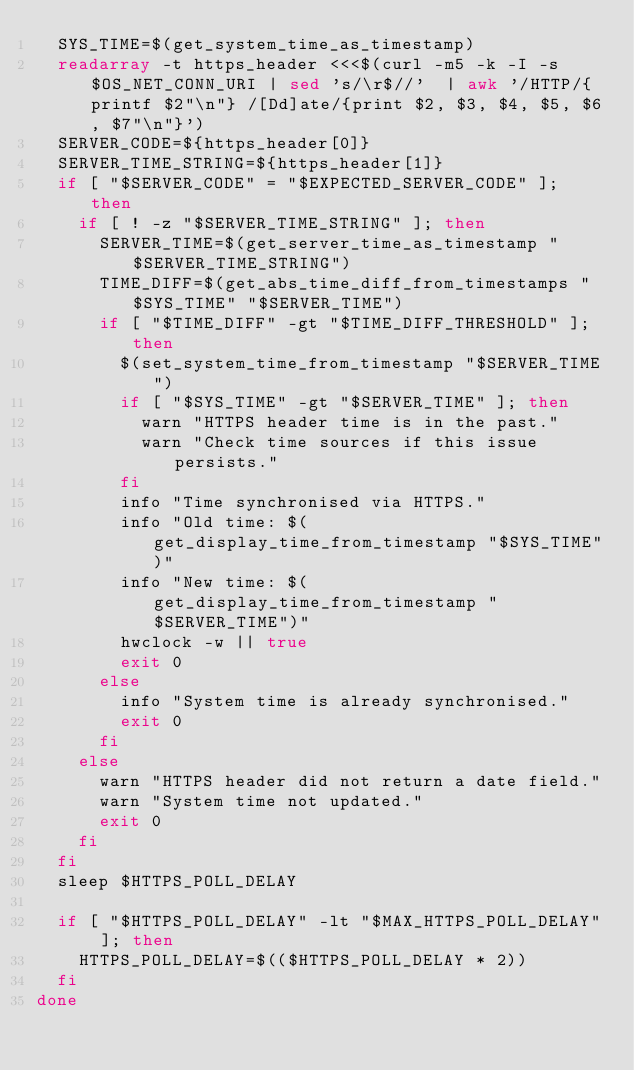Convert code to text. <code><loc_0><loc_0><loc_500><loc_500><_Bash_>	SYS_TIME=$(get_system_time_as_timestamp)
	readarray -t https_header <<<$(curl -m5 -k -I -s $OS_NET_CONN_URI | sed 's/\r$//'  | awk '/HTTP/{printf $2"\n"} /[Dd]ate/{print $2, $3, $4, $5, $6, $7"\n"}')
	SERVER_CODE=${https_header[0]}
	SERVER_TIME_STRING=${https_header[1]}
	if [ "$SERVER_CODE" = "$EXPECTED_SERVER_CODE" ]; then
		if [ ! -z "$SERVER_TIME_STRING" ]; then
			SERVER_TIME=$(get_server_time_as_timestamp "$SERVER_TIME_STRING")
			TIME_DIFF=$(get_abs_time_diff_from_timestamps "$SYS_TIME" "$SERVER_TIME")
			if [ "$TIME_DIFF" -gt "$TIME_DIFF_THRESHOLD" ]; then
				$(set_system_time_from_timestamp "$SERVER_TIME")
				if [ "$SYS_TIME" -gt "$SERVER_TIME" ]; then
					warn "HTTPS header time is in the past."
					warn "Check time sources if this issue persists."
				fi
				info "Time synchronised via HTTPS."
				info "Old time: $(get_display_time_from_timestamp "$SYS_TIME")"
				info "New time: $(get_display_time_from_timestamp "$SERVER_TIME")"
				hwclock -w || true
				exit 0
			else
				info "System time is already synchronised."
				exit 0
			fi
		else
			warn "HTTPS header did not return a date field."
			warn "System time not updated."
			exit 0
		fi
	fi
	sleep $HTTPS_POLL_DELAY

	if [ "$HTTPS_POLL_DELAY" -lt "$MAX_HTTPS_POLL_DELAY" ]; then
		HTTPS_POLL_DELAY=$(($HTTPS_POLL_DELAY * 2))
	fi
done
</code> 